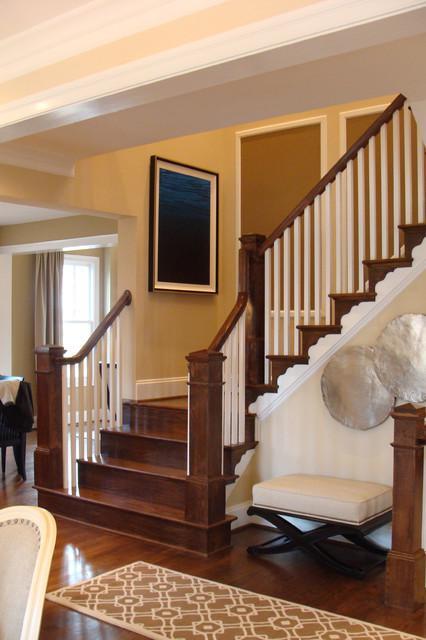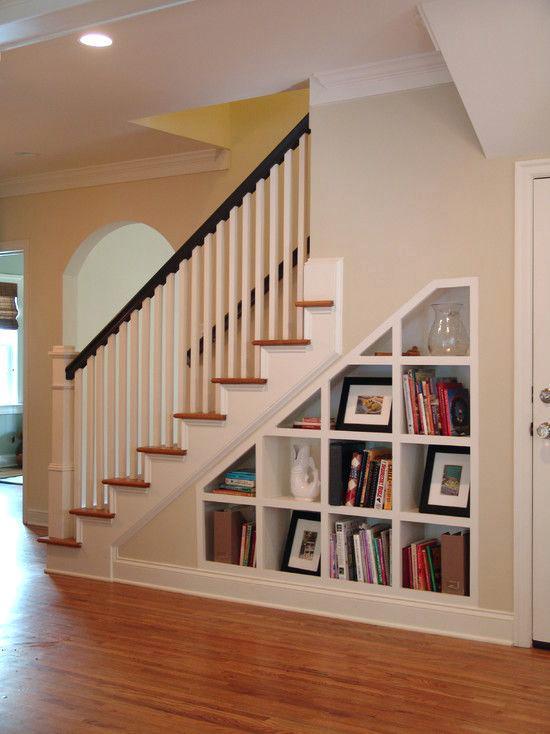The first image is the image on the left, the second image is the image on the right. Evaluate the accuracy of this statement regarding the images: "In at least one of the images, the piece of furniture near the bottom of the stairs has a vase of flowers on it.". Is it true? Answer yes or no. No. The first image is the image on the left, the second image is the image on the right. Examine the images to the left and right. Is the description "Framed pictures follow the line of the stairway in the image on the right." accurate? Answer yes or no. No. 